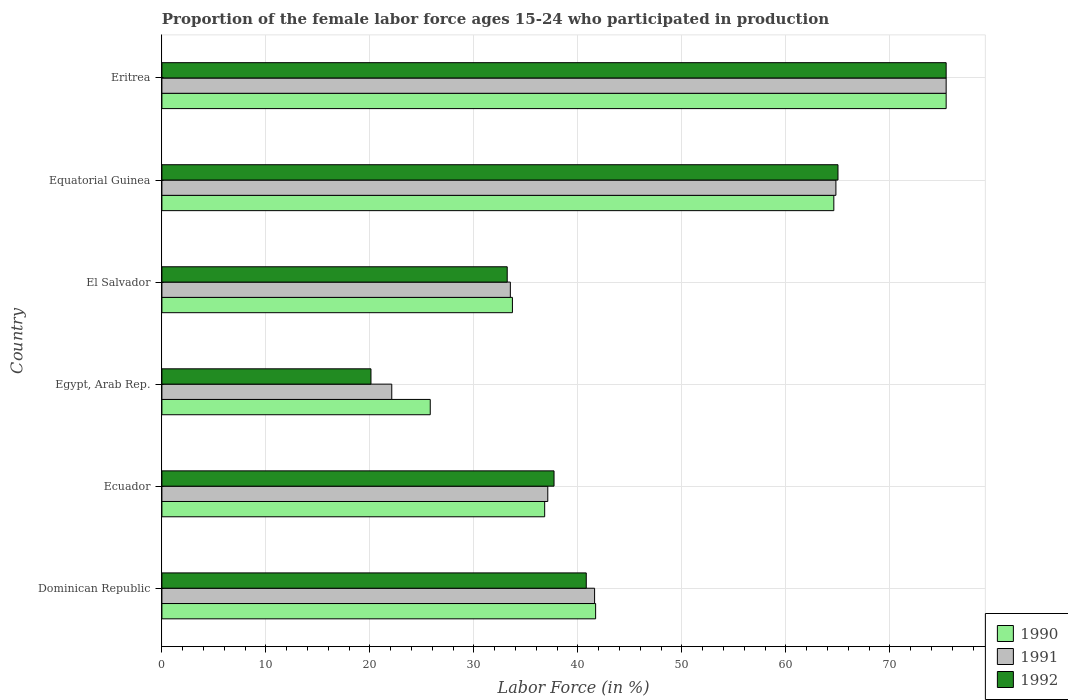How many different coloured bars are there?
Your answer should be compact. 3. What is the label of the 4th group of bars from the top?
Keep it short and to the point. Egypt, Arab Rep. What is the proportion of the female labor force who participated in production in 1992 in Dominican Republic?
Make the answer very short. 40.8. Across all countries, what is the maximum proportion of the female labor force who participated in production in 1990?
Ensure brevity in your answer.  75.4. Across all countries, what is the minimum proportion of the female labor force who participated in production in 1990?
Your response must be concise. 25.8. In which country was the proportion of the female labor force who participated in production in 1992 maximum?
Give a very brief answer. Eritrea. In which country was the proportion of the female labor force who participated in production in 1990 minimum?
Provide a succinct answer. Egypt, Arab Rep. What is the total proportion of the female labor force who participated in production in 1992 in the graph?
Offer a very short reply. 272.2. What is the difference between the proportion of the female labor force who participated in production in 1991 in Ecuador and that in El Salvador?
Make the answer very short. 3.6. What is the difference between the proportion of the female labor force who participated in production in 1992 in El Salvador and the proportion of the female labor force who participated in production in 1990 in Ecuador?
Your response must be concise. -3.6. What is the average proportion of the female labor force who participated in production in 1991 per country?
Your response must be concise. 45.75. What is the difference between the proportion of the female labor force who participated in production in 1992 and proportion of the female labor force who participated in production in 1991 in Eritrea?
Provide a short and direct response. 0. What is the ratio of the proportion of the female labor force who participated in production in 1990 in Equatorial Guinea to that in Eritrea?
Make the answer very short. 0.86. Is the difference between the proportion of the female labor force who participated in production in 1992 in Egypt, Arab Rep. and El Salvador greater than the difference between the proportion of the female labor force who participated in production in 1991 in Egypt, Arab Rep. and El Salvador?
Give a very brief answer. No. What is the difference between the highest and the second highest proportion of the female labor force who participated in production in 1990?
Your response must be concise. 10.8. What is the difference between the highest and the lowest proportion of the female labor force who participated in production in 1990?
Give a very brief answer. 49.6. In how many countries, is the proportion of the female labor force who participated in production in 1991 greater than the average proportion of the female labor force who participated in production in 1991 taken over all countries?
Offer a very short reply. 2. Is the sum of the proportion of the female labor force who participated in production in 1992 in El Salvador and Equatorial Guinea greater than the maximum proportion of the female labor force who participated in production in 1990 across all countries?
Ensure brevity in your answer.  Yes. What does the 3rd bar from the bottom in Egypt, Arab Rep. represents?
Your answer should be compact. 1992. How many bars are there?
Offer a terse response. 18. Are all the bars in the graph horizontal?
Offer a terse response. Yes. How many countries are there in the graph?
Provide a short and direct response. 6. What is the difference between two consecutive major ticks on the X-axis?
Offer a very short reply. 10. Are the values on the major ticks of X-axis written in scientific E-notation?
Offer a terse response. No. Does the graph contain any zero values?
Offer a very short reply. No. Does the graph contain grids?
Your response must be concise. Yes. Where does the legend appear in the graph?
Your answer should be very brief. Bottom right. How many legend labels are there?
Provide a succinct answer. 3. How are the legend labels stacked?
Your answer should be very brief. Vertical. What is the title of the graph?
Provide a succinct answer. Proportion of the female labor force ages 15-24 who participated in production. What is the label or title of the Y-axis?
Offer a terse response. Country. What is the Labor Force (in %) in 1990 in Dominican Republic?
Your response must be concise. 41.7. What is the Labor Force (in %) of 1991 in Dominican Republic?
Your answer should be very brief. 41.6. What is the Labor Force (in %) of 1992 in Dominican Republic?
Offer a terse response. 40.8. What is the Labor Force (in %) of 1990 in Ecuador?
Your answer should be very brief. 36.8. What is the Labor Force (in %) of 1991 in Ecuador?
Offer a very short reply. 37.1. What is the Labor Force (in %) of 1992 in Ecuador?
Ensure brevity in your answer.  37.7. What is the Labor Force (in %) of 1990 in Egypt, Arab Rep.?
Offer a very short reply. 25.8. What is the Labor Force (in %) in 1991 in Egypt, Arab Rep.?
Make the answer very short. 22.1. What is the Labor Force (in %) in 1992 in Egypt, Arab Rep.?
Your response must be concise. 20.1. What is the Labor Force (in %) of 1990 in El Salvador?
Make the answer very short. 33.7. What is the Labor Force (in %) of 1991 in El Salvador?
Provide a succinct answer. 33.5. What is the Labor Force (in %) in 1992 in El Salvador?
Give a very brief answer. 33.2. What is the Labor Force (in %) of 1990 in Equatorial Guinea?
Your answer should be very brief. 64.6. What is the Labor Force (in %) of 1991 in Equatorial Guinea?
Your response must be concise. 64.8. What is the Labor Force (in %) of 1990 in Eritrea?
Provide a short and direct response. 75.4. What is the Labor Force (in %) in 1991 in Eritrea?
Keep it short and to the point. 75.4. What is the Labor Force (in %) in 1992 in Eritrea?
Provide a succinct answer. 75.4. Across all countries, what is the maximum Labor Force (in %) in 1990?
Your answer should be very brief. 75.4. Across all countries, what is the maximum Labor Force (in %) in 1991?
Make the answer very short. 75.4. Across all countries, what is the maximum Labor Force (in %) in 1992?
Provide a short and direct response. 75.4. Across all countries, what is the minimum Labor Force (in %) of 1990?
Provide a short and direct response. 25.8. Across all countries, what is the minimum Labor Force (in %) of 1991?
Provide a succinct answer. 22.1. Across all countries, what is the minimum Labor Force (in %) in 1992?
Keep it short and to the point. 20.1. What is the total Labor Force (in %) in 1990 in the graph?
Offer a terse response. 278. What is the total Labor Force (in %) of 1991 in the graph?
Offer a very short reply. 274.5. What is the total Labor Force (in %) in 1992 in the graph?
Your answer should be compact. 272.2. What is the difference between the Labor Force (in %) of 1990 in Dominican Republic and that in Ecuador?
Your response must be concise. 4.9. What is the difference between the Labor Force (in %) in 1991 in Dominican Republic and that in Ecuador?
Give a very brief answer. 4.5. What is the difference between the Labor Force (in %) of 1991 in Dominican Republic and that in Egypt, Arab Rep.?
Ensure brevity in your answer.  19.5. What is the difference between the Labor Force (in %) of 1992 in Dominican Republic and that in Egypt, Arab Rep.?
Offer a terse response. 20.7. What is the difference between the Labor Force (in %) of 1990 in Dominican Republic and that in El Salvador?
Ensure brevity in your answer.  8. What is the difference between the Labor Force (in %) in 1991 in Dominican Republic and that in El Salvador?
Ensure brevity in your answer.  8.1. What is the difference between the Labor Force (in %) in 1992 in Dominican Republic and that in El Salvador?
Make the answer very short. 7.6. What is the difference between the Labor Force (in %) of 1990 in Dominican Republic and that in Equatorial Guinea?
Keep it short and to the point. -22.9. What is the difference between the Labor Force (in %) of 1991 in Dominican Republic and that in Equatorial Guinea?
Provide a succinct answer. -23.2. What is the difference between the Labor Force (in %) of 1992 in Dominican Republic and that in Equatorial Guinea?
Make the answer very short. -24.2. What is the difference between the Labor Force (in %) in 1990 in Dominican Republic and that in Eritrea?
Ensure brevity in your answer.  -33.7. What is the difference between the Labor Force (in %) of 1991 in Dominican Republic and that in Eritrea?
Your answer should be very brief. -33.8. What is the difference between the Labor Force (in %) in 1992 in Dominican Republic and that in Eritrea?
Offer a very short reply. -34.6. What is the difference between the Labor Force (in %) in 1990 in Ecuador and that in Egypt, Arab Rep.?
Ensure brevity in your answer.  11. What is the difference between the Labor Force (in %) of 1991 in Ecuador and that in El Salvador?
Your response must be concise. 3.6. What is the difference between the Labor Force (in %) of 1992 in Ecuador and that in El Salvador?
Give a very brief answer. 4.5. What is the difference between the Labor Force (in %) of 1990 in Ecuador and that in Equatorial Guinea?
Keep it short and to the point. -27.8. What is the difference between the Labor Force (in %) in 1991 in Ecuador and that in Equatorial Guinea?
Your answer should be compact. -27.7. What is the difference between the Labor Force (in %) in 1992 in Ecuador and that in Equatorial Guinea?
Your answer should be very brief. -27.3. What is the difference between the Labor Force (in %) in 1990 in Ecuador and that in Eritrea?
Your response must be concise. -38.6. What is the difference between the Labor Force (in %) in 1991 in Ecuador and that in Eritrea?
Offer a very short reply. -38.3. What is the difference between the Labor Force (in %) in 1992 in Ecuador and that in Eritrea?
Your response must be concise. -37.7. What is the difference between the Labor Force (in %) of 1990 in Egypt, Arab Rep. and that in El Salvador?
Your answer should be compact. -7.9. What is the difference between the Labor Force (in %) in 1990 in Egypt, Arab Rep. and that in Equatorial Guinea?
Provide a succinct answer. -38.8. What is the difference between the Labor Force (in %) in 1991 in Egypt, Arab Rep. and that in Equatorial Guinea?
Keep it short and to the point. -42.7. What is the difference between the Labor Force (in %) of 1992 in Egypt, Arab Rep. and that in Equatorial Guinea?
Make the answer very short. -44.9. What is the difference between the Labor Force (in %) of 1990 in Egypt, Arab Rep. and that in Eritrea?
Provide a succinct answer. -49.6. What is the difference between the Labor Force (in %) of 1991 in Egypt, Arab Rep. and that in Eritrea?
Offer a terse response. -53.3. What is the difference between the Labor Force (in %) in 1992 in Egypt, Arab Rep. and that in Eritrea?
Provide a short and direct response. -55.3. What is the difference between the Labor Force (in %) in 1990 in El Salvador and that in Equatorial Guinea?
Provide a succinct answer. -30.9. What is the difference between the Labor Force (in %) of 1991 in El Salvador and that in Equatorial Guinea?
Provide a short and direct response. -31.3. What is the difference between the Labor Force (in %) in 1992 in El Salvador and that in Equatorial Guinea?
Your response must be concise. -31.8. What is the difference between the Labor Force (in %) of 1990 in El Salvador and that in Eritrea?
Make the answer very short. -41.7. What is the difference between the Labor Force (in %) of 1991 in El Salvador and that in Eritrea?
Make the answer very short. -41.9. What is the difference between the Labor Force (in %) in 1992 in El Salvador and that in Eritrea?
Offer a very short reply. -42.2. What is the difference between the Labor Force (in %) in 1990 in Dominican Republic and the Labor Force (in %) in 1991 in Ecuador?
Offer a terse response. 4.6. What is the difference between the Labor Force (in %) in 1990 in Dominican Republic and the Labor Force (in %) in 1992 in Ecuador?
Your answer should be compact. 4. What is the difference between the Labor Force (in %) of 1991 in Dominican Republic and the Labor Force (in %) of 1992 in Ecuador?
Provide a succinct answer. 3.9. What is the difference between the Labor Force (in %) in 1990 in Dominican Republic and the Labor Force (in %) in 1991 in Egypt, Arab Rep.?
Your answer should be compact. 19.6. What is the difference between the Labor Force (in %) in 1990 in Dominican Republic and the Labor Force (in %) in 1992 in Egypt, Arab Rep.?
Offer a terse response. 21.6. What is the difference between the Labor Force (in %) of 1991 in Dominican Republic and the Labor Force (in %) of 1992 in Egypt, Arab Rep.?
Offer a very short reply. 21.5. What is the difference between the Labor Force (in %) in 1990 in Dominican Republic and the Labor Force (in %) in 1992 in El Salvador?
Your answer should be compact. 8.5. What is the difference between the Labor Force (in %) in 1990 in Dominican Republic and the Labor Force (in %) in 1991 in Equatorial Guinea?
Make the answer very short. -23.1. What is the difference between the Labor Force (in %) in 1990 in Dominican Republic and the Labor Force (in %) in 1992 in Equatorial Guinea?
Provide a short and direct response. -23.3. What is the difference between the Labor Force (in %) of 1991 in Dominican Republic and the Labor Force (in %) of 1992 in Equatorial Guinea?
Provide a succinct answer. -23.4. What is the difference between the Labor Force (in %) in 1990 in Dominican Republic and the Labor Force (in %) in 1991 in Eritrea?
Offer a terse response. -33.7. What is the difference between the Labor Force (in %) of 1990 in Dominican Republic and the Labor Force (in %) of 1992 in Eritrea?
Provide a succinct answer. -33.7. What is the difference between the Labor Force (in %) in 1991 in Dominican Republic and the Labor Force (in %) in 1992 in Eritrea?
Your answer should be compact. -33.8. What is the difference between the Labor Force (in %) in 1990 in Ecuador and the Labor Force (in %) in 1991 in Egypt, Arab Rep.?
Your response must be concise. 14.7. What is the difference between the Labor Force (in %) in 1990 in Ecuador and the Labor Force (in %) in 1992 in Egypt, Arab Rep.?
Give a very brief answer. 16.7. What is the difference between the Labor Force (in %) in 1991 in Ecuador and the Labor Force (in %) in 1992 in Egypt, Arab Rep.?
Provide a short and direct response. 17. What is the difference between the Labor Force (in %) of 1990 in Ecuador and the Labor Force (in %) of 1992 in El Salvador?
Offer a very short reply. 3.6. What is the difference between the Labor Force (in %) in 1991 in Ecuador and the Labor Force (in %) in 1992 in El Salvador?
Offer a terse response. 3.9. What is the difference between the Labor Force (in %) in 1990 in Ecuador and the Labor Force (in %) in 1991 in Equatorial Guinea?
Offer a terse response. -28. What is the difference between the Labor Force (in %) in 1990 in Ecuador and the Labor Force (in %) in 1992 in Equatorial Guinea?
Your answer should be compact. -28.2. What is the difference between the Labor Force (in %) in 1991 in Ecuador and the Labor Force (in %) in 1992 in Equatorial Guinea?
Keep it short and to the point. -27.9. What is the difference between the Labor Force (in %) in 1990 in Ecuador and the Labor Force (in %) in 1991 in Eritrea?
Give a very brief answer. -38.6. What is the difference between the Labor Force (in %) of 1990 in Ecuador and the Labor Force (in %) of 1992 in Eritrea?
Ensure brevity in your answer.  -38.6. What is the difference between the Labor Force (in %) of 1991 in Ecuador and the Labor Force (in %) of 1992 in Eritrea?
Give a very brief answer. -38.3. What is the difference between the Labor Force (in %) of 1990 in Egypt, Arab Rep. and the Labor Force (in %) of 1992 in El Salvador?
Make the answer very short. -7.4. What is the difference between the Labor Force (in %) in 1990 in Egypt, Arab Rep. and the Labor Force (in %) in 1991 in Equatorial Guinea?
Your answer should be very brief. -39. What is the difference between the Labor Force (in %) in 1990 in Egypt, Arab Rep. and the Labor Force (in %) in 1992 in Equatorial Guinea?
Provide a succinct answer. -39.2. What is the difference between the Labor Force (in %) of 1991 in Egypt, Arab Rep. and the Labor Force (in %) of 1992 in Equatorial Guinea?
Ensure brevity in your answer.  -42.9. What is the difference between the Labor Force (in %) of 1990 in Egypt, Arab Rep. and the Labor Force (in %) of 1991 in Eritrea?
Your response must be concise. -49.6. What is the difference between the Labor Force (in %) of 1990 in Egypt, Arab Rep. and the Labor Force (in %) of 1992 in Eritrea?
Your answer should be compact. -49.6. What is the difference between the Labor Force (in %) in 1991 in Egypt, Arab Rep. and the Labor Force (in %) in 1992 in Eritrea?
Ensure brevity in your answer.  -53.3. What is the difference between the Labor Force (in %) of 1990 in El Salvador and the Labor Force (in %) of 1991 in Equatorial Guinea?
Your answer should be compact. -31.1. What is the difference between the Labor Force (in %) of 1990 in El Salvador and the Labor Force (in %) of 1992 in Equatorial Guinea?
Your answer should be compact. -31.3. What is the difference between the Labor Force (in %) in 1991 in El Salvador and the Labor Force (in %) in 1992 in Equatorial Guinea?
Provide a short and direct response. -31.5. What is the difference between the Labor Force (in %) in 1990 in El Salvador and the Labor Force (in %) in 1991 in Eritrea?
Provide a succinct answer. -41.7. What is the difference between the Labor Force (in %) in 1990 in El Salvador and the Labor Force (in %) in 1992 in Eritrea?
Offer a very short reply. -41.7. What is the difference between the Labor Force (in %) in 1991 in El Salvador and the Labor Force (in %) in 1992 in Eritrea?
Your answer should be very brief. -41.9. What is the difference between the Labor Force (in %) of 1990 in Equatorial Guinea and the Labor Force (in %) of 1991 in Eritrea?
Make the answer very short. -10.8. What is the difference between the Labor Force (in %) of 1990 in Equatorial Guinea and the Labor Force (in %) of 1992 in Eritrea?
Provide a short and direct response. -10.8. What is the difference between the Labor Force (in %) in 1991 in Equatorial Guinea and the Labor Force (in %) in 1992 in Eritrea?
Offer a terse response. -10.6. What is the average Labor Force (in %) in 1990 per country?
Your answer should be very brief. 46.33. What is the average Labor Force (in %) in 1991 per country?
Offer a very short reply. 45.75. What is the average Labor Force (in %) in 1992 per country?
Provide a succinct answer. 45.37. What is the difference between the Labor Force (in %) of 1990 and Labor Force (in %) of 1992 in Dominican Republic?
Your answer should be compact. 0.9. What is the difference between the Labor Force (in %) of 1990 and Labor Force (in %) of 1991 in Ecuador?
Provide a succinct answer. -0.3. What is the difference between the Labor Force (in %) in 1991 and Labor Force (in %) in 1992 in Ecuador?
Offer a very short reply. -0.6. What is the difference between the Labor Force (in %) in 1990 and Labor Force (in %) in 1992 in Egypt, Arab Rep.?
Your answer should be very brief. 5.7. What is the difference between the Labor Force (in %) in 1991 and Labor Force (in %) in 1992 in Egypt, Arab Rep.?
Offer a terse response. 2. What is the difference between the Labor Force (in %) in 1990 and Labor Force (in %) in 1991 in El Salvador?
Offer a very short reply. 0.2. What is the difference between the Labor Force (in %) of 1990 and Labor Force (in %) of 1992 in El Salvador?
Provide a succinct answer. 0.5. What is the difference between the Labor Force (in %) in 1991 and Labor Force (in %) in 1992 in El Salvador?
Offer a very short reply. 0.3. What is the difference between the Labor Force (in %) of 1991 and Labor Force (in %) of 1992 in Equatorial Guinea?
Offer a very short reply. -0.2. What is the difference between the Labor Force (in %) in 1991 and Labor Force (in %) in 1992 in Eritrea?
Keep it short and to the point. 0. What is the ratio of the Labor Force (in %) in 1990 in Dominican Republic to that in Ecuador?
Your response must be concise. 1.13. What is the ratio of the Labor Force (in %) of 1991 in Dominican Republic to that in Ecuador?
Provide a succinct answer. 1.12. What is the ratio of the Labor Force (in %) of 1992 in Dominican Republic to that in Ecuador?
Make the answer very short. 1.08. What is the ratio of the Labor Force (in %) in 1990 in Dominican Republic to that in Egypt, Arab Rep.?
Offer a terse response. 1.62. What is the ratio of the Labor Force (in %) in 1991 in Dominican Republic to that in Egypt, Arab Rep.?
Keep it short and to the point. 1.88. What is the ratio of the Labor Force (in %) in 1992 in Dominican Republic to that in Egypt, Arab Rep.?
Ensure brevity in your answer.  2.03. What is the ratio of the Labor Force (in %) of 1990 in Dominican Republic to that in El Salvador?
Ensure brevity in your answer.  1.24. What is the ratio of the Labor Force (in %) of 1991 in Dominican Republic to that in El Salvador?
Ensure brevity in your answer.  1.24. What is the ratio of the Labor Force (in %) of 1992 in Dominican Republic to that in El Salvador?
Your answer should be compact. 1.23. What is the ratio of the Labor Force (in %) in 1990 in Dominican Republic to that in Equatorial Guinea?
Provide a succinct answer. 0.65. What is the ratio of the Labor Force (in %) of 1991 in Dominican Republic to that in Equatorial Guinea?
Your response must be concise. 0.64. What is the ratio of the Labor Force (in %) in 1992 in Dominican Republic to that in Equatorial Guinea?
Provide a succinct answer. 0.63. What is the ratio of the Labor Force (in %) in 1990 in Dominican Republic to that in Eritrea?
Offer a terse response. 0.55. What is the ratio of the Labor Force (in %) in 1991 in Dominican Republic to that in Eritrea?
Provide a short and direct response. 0.55. What is the ratio of the Labor Force (in %) of 1992 in Dominican Republic to that in Eritrea?
Offer a very short reply. 0.54. What is the ratio of the Labor Force (in %) in 1990 in Ecuador to that in Egypt, Arab Rep.?
Offer a very short reply. 1.43. What is the ratio of the Labor Force (in %) of 1991 in Ecuador to that in Egypt, Arab Rep.?
Ensure brevity in your answer.  1.68. What is the ratio of the Labor Force (in %) in 1992 in Ecuador to that in Egypt, Arab Rep.?
Provide a succinct answer. 1.88. What is the ratio of the Labor Force (in %) in 1990 in Ecuador to that in El Salvador?
Your response must be concise. 1.09. What is the ratio of the Labor Force (in %) of 1991 in Ecuador to that in El Salvador?
Keep it short and to the point. 1.11. What is the ratio of the Labor Force (in %) in 1992 in Ecuador to that in El Salvador?
Offer a very short reply. 1.14. What is the ratio of the Labor Force (in %) in 1990 in Ecuador to that in Equatorial Guinea?
Ensure brevity in your answer.  0.57. What is the ratio of the Labor Force (in %) of 1991 in Ecuador to that in Equatorial Guinea?
Your answer should be very brief. 0.57. What is the ratio of the Labor Force (in %) of 1992 in Ecuador to that in Equatorial Guinea?
Give a very brief answer. 0.58. What is the ratio of the Labor Force (in %) in 1990 in Ecuador to that in Eritrea?
Offer a very short reply. 0.49. What is the ratio of the Labor Force (in %) in 1991 in Ecuador to that in Eritrea?
Provide a short and direct response. 0.49. What is the ratio of the Labor Force (in %) of 1990 in Egypt, Arab Rep. to that in El Salvador?
Make the answer very short. 0.77. What is the ratio of the Labor Force (in %) of 1991 in Egypt, Arab Rep. to that in El Salvador?
Offer a very short reply. 0.66. What is the ratio of the Labor Force (in %) in 1992 in Egypt, Arab Rep. to that in El Salvador?
Your answer should be compact. 0.61. What is the ratio of the Labor Force (in %) in 1990 in Egypt, Arab Rep. to that in Equatorial Guinea?
Provide a short and direct response. 0.4. What is the ratio of the Labor Force (in %) of 1991 in Egypt, Arab Rep. to that in Equatorial Guinea?
Offer a very short reply. 0.34. What is the ratio of the Labor Force (in %) of 1992 in Egypt, Arab Rep. to that in Equatorial Guinea?
Your answer should be very brief. 0.31. What is the ratio of the Labor Force (in %) in 1990 in Egypt, Arab Rep. to that in Eritrea?
Make the answer very short. 0.34. What is the ratio of the Labor Force (in %) of 1991 in Egypt, Arab Rep. to that in Eritrea?
Your answer should be very brief. 0.29. What is the ratio of the Labor Force (in %) in 1992 in Egypt, Arab Rep. to that in Eritrea?
Your answer should be compact. 0.27. What is the ratio of the Labor Force (in %) in 1990 in El Salvador to that in Equatorial Guinea?
Offer a very short reply. 0.52. What is the ratio of the Labor Force (in %) in 1991 in El Salvador to that in Equatorial Guinea?
Make the answer very short. 0.52. What is the ratio of the Labor Force (in %) of 1992 in El Salvador to that in Equatorial Guinea?
Give a very brief answer. 0.51. What is the ratio of the Labor Force (in %) of 1990 in El Salvador to that in Eritrea?
Give a very brief answer. 0.45. What is the ratio of the Labor Force (in %) in 1991 in El Salvador to that in Eritrea?
Ensure brevity in your answer.  0.44. What is the ratio of the Labor Force (in %) of 1992 in El Salvador to that in Eritrea?
Provide a succinct answer. 0.44. What is the ratio of the Labor Force (in %) of 1990 in Equatorial Guinea to that in Eritrea?
Offer a very short reply. 0.86. What is the ratio of the Labor Force (in %) in 1991 in Equatorial Guinea to that in Eritrea?
Offer a terse response. 0.86. What is the ratio of the Labor Force (in %) of 1992 in Equatorial Guinea to that in Eritrea?
Your response must be concise. 0.86. What is the difference between the highest and the second highest Labor Force (in %) of 1991?
Your response must be concise. 10.6. What is the difference between the highest and the second highest Labor Force (in %) in 1992?
Your answer should be very brief. 10.4. What is the difference between the highest and the lowest Labor Force (in %) of 1990?
Give a very brief answer. 49.6. What is the difference between the highest and the lowest Labor Force (in %) in 1991?
Provide a succinct answer. 53.3. What is the difference between the highest and the lowest Labor Force (in %) in 1992?
Keep it short and to the point. 55.3. 